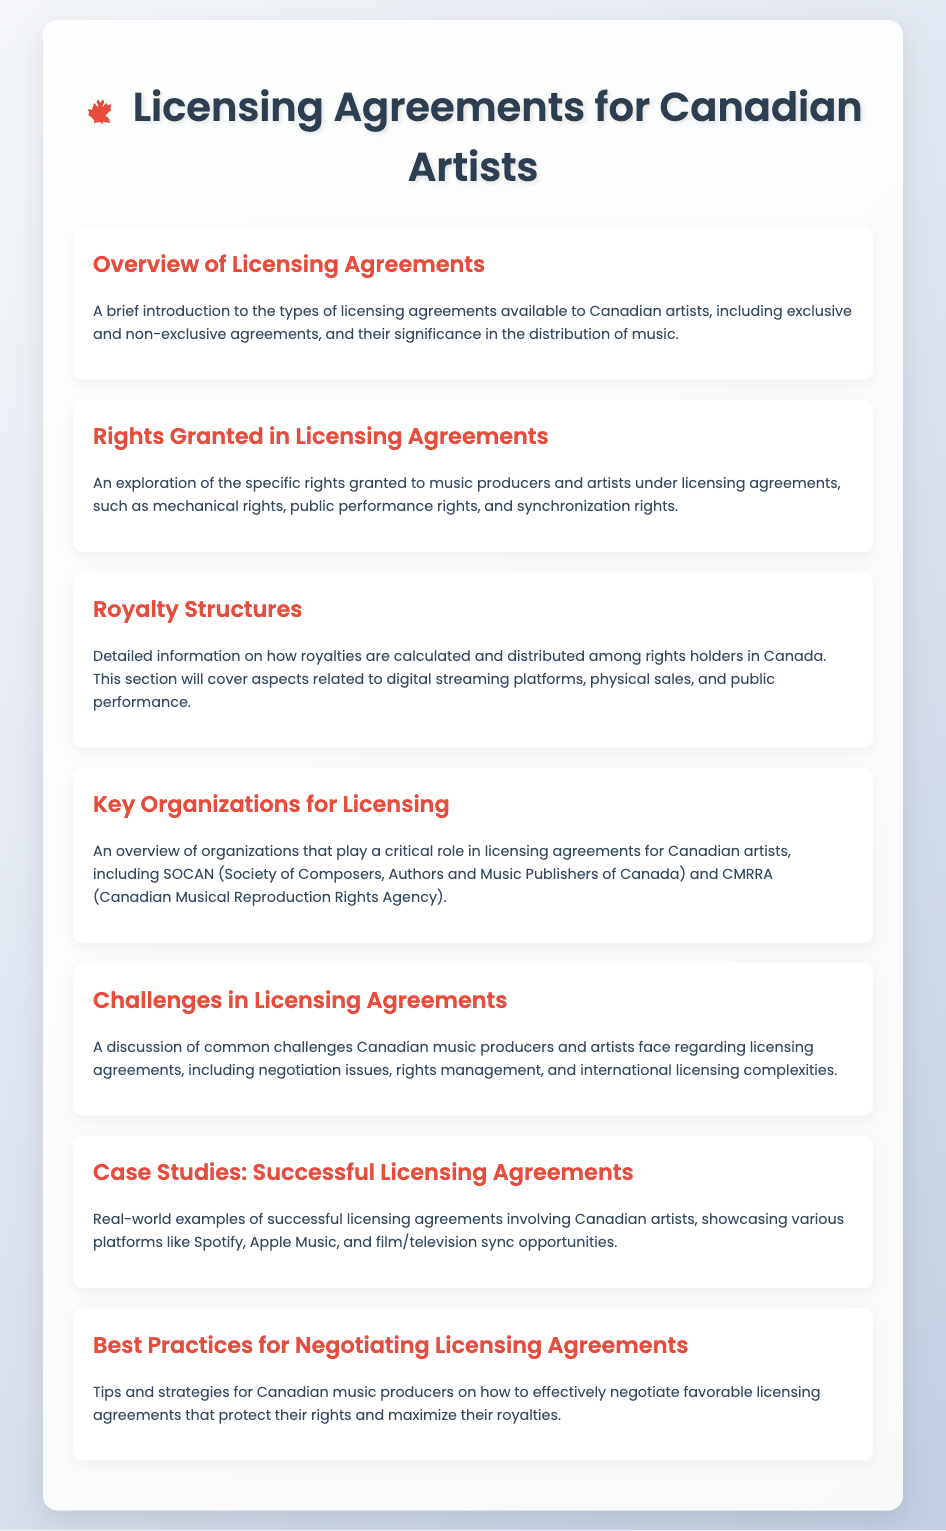What is the first item on the menu? The first item on the menu is "Overview of Licensing Agreements."
Answer: Overview of Licensing Agreements What organization is responsible for composers, authors, and publishers in Canada? The organization mentioned is SOCAN (Society of Composers, Authors and Music Publishers of Canada).
Answer: SOCAN Which section covers royalty calculations? The section that covers royalty calculations is "Royalty Structures."
Answer: Royalty Structures What type of rights are explored under licensing agreements? The rights explored include mechanical rights, public performance rights, and synchronization rights.
Answer: mechanical rights, public performance rights, and synchronization rights What is a common challenge mentioned in licensing agreements? A common challenge mentioned is negotiation issues.
Answer: negotiation issues How many case studies are provided in the document? The document provides real-world examples, indicated as one section called "Case Studies: Successful Licensing Agreements," but does not specify the number.
Answer: Case Studies: Successful Licensing Agreements What is the last item on the menu? The last item on the menu is "Best Practices for Negotiating Licensing Agreements."
Answer: Best Practices for Negotiating Licensing Agreements What is the color theme of the document? The color theme features a linear gradient from light gray to a light blueish tone.
Answer: light gray to a light blueish tone 